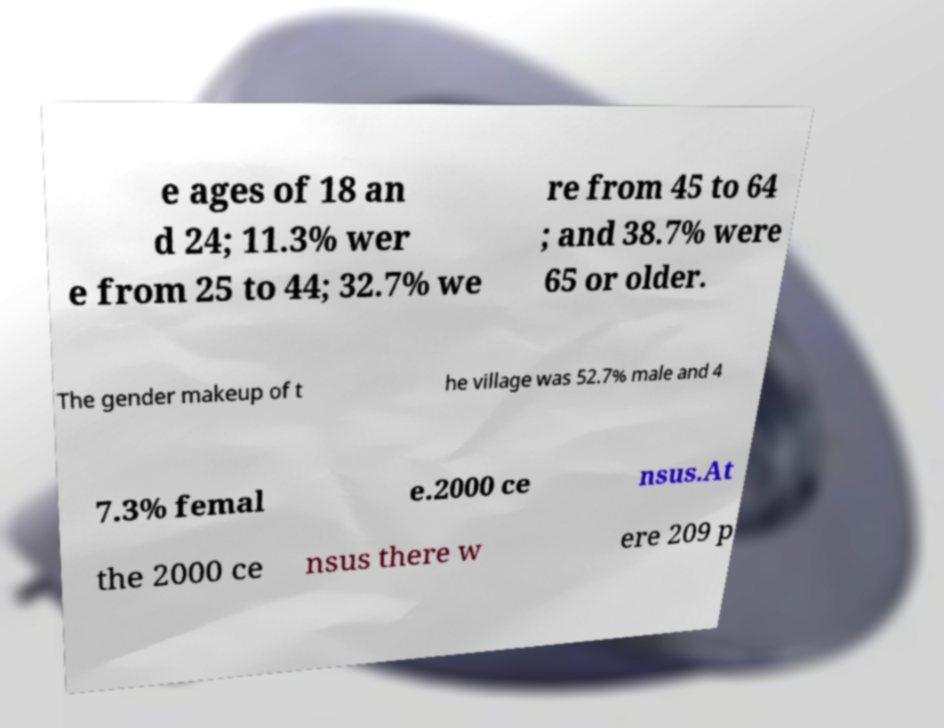Can you read and provide the text displayed in the image?This photo seems to have some interesting text. Can you extract and type it out for me? e ages of 18 an d 24; 11.3% wer e from 25 to 44; 32.7% we re from 45 to 64 ; and 38.7% were 65 or older. The gender makeup of t he village was 52.7% male and 4 7.3% femal e.2000 ce nsus.At the 2000 ce nsus there w ere 209 p 